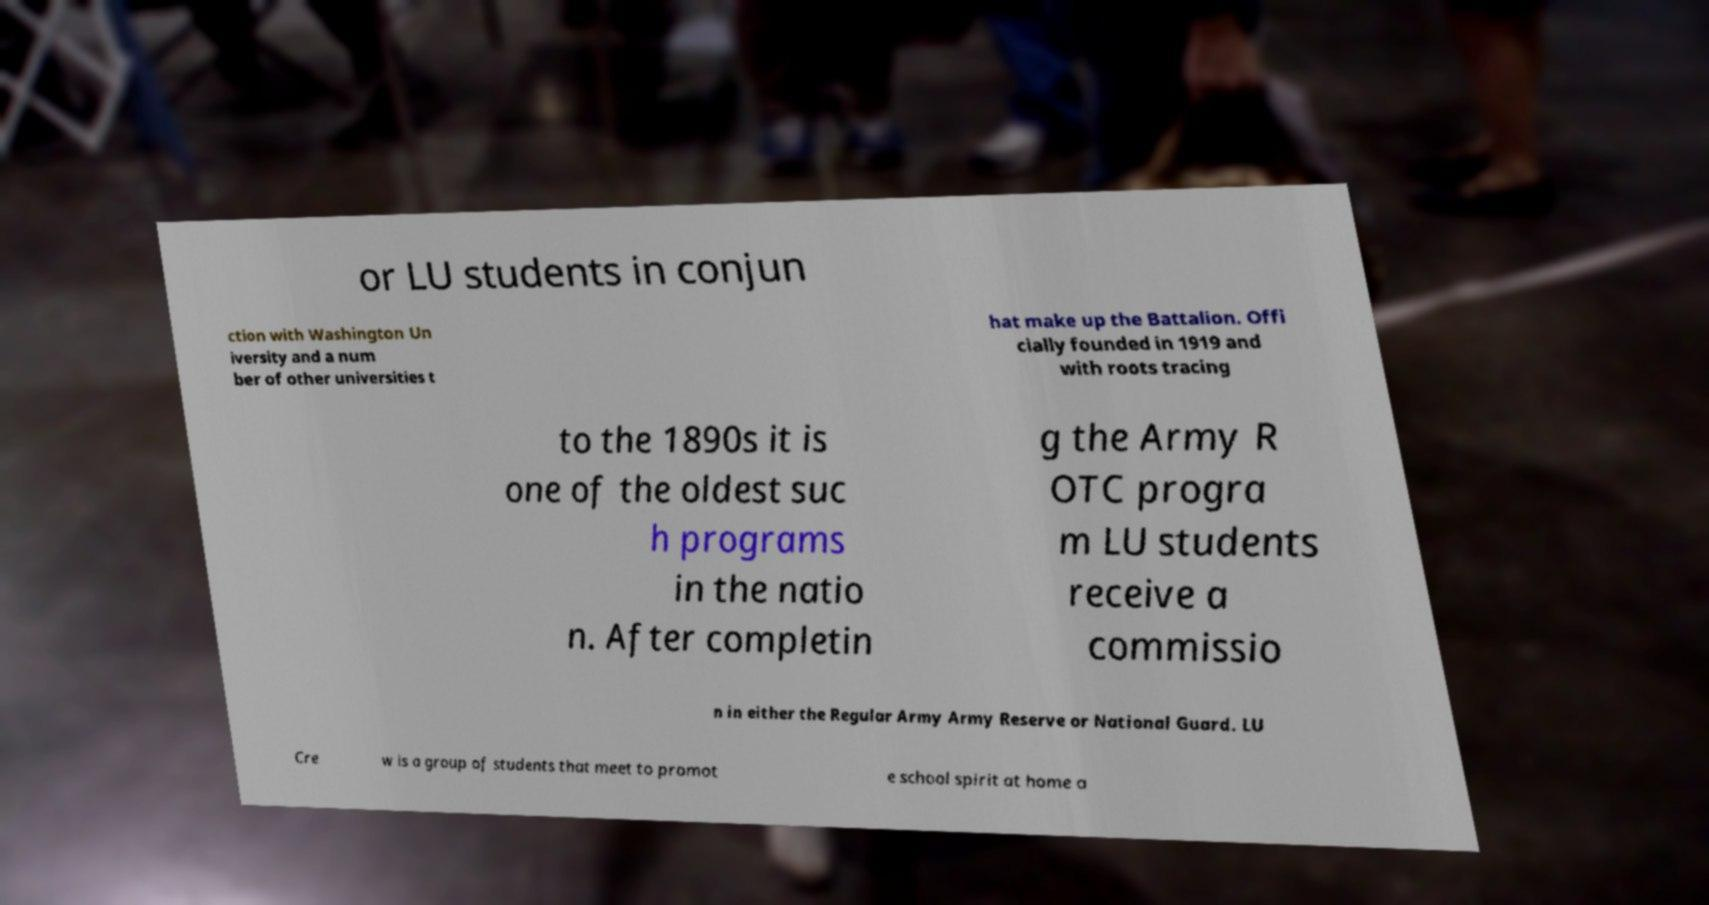For documentation purposes, I need the text within this image transcribed. Could you provide that? or LU students in conjun ction with Washington Un iversity and a num ber of other universities t hat make up the Battalion. Offi cially founded in 1919 and with roots tracing to the 1890s it is one of the oldest suc h programs in the natio n. After completin g the Army R OTC progra m LU students receive a commissio n in either the Regular Army Army Reserve or National Guard. LU Cre w is a group of students that meet to promot e school spirit at home a 